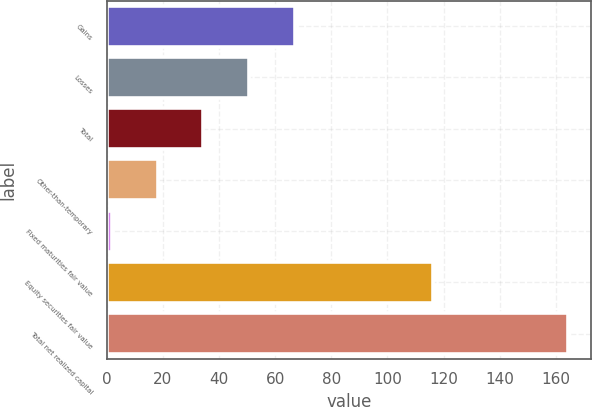Convert chart. <chart><loc_0><loc_0><loc_500><loc_500><bar_chart><fcel>Gains<fcel>Losses<fcel>Total<fcel>Other-than-temporary<fcel>Fixed maturities fair value<fcel>Equity securities fair value<fcel>Total net realized capital<nl><fcel>66.9<fcel>50.65<fcel>34.4<fcel>18.15<fcel>1.9<fcel>116.2<fcel>164.4<nl></chart> 